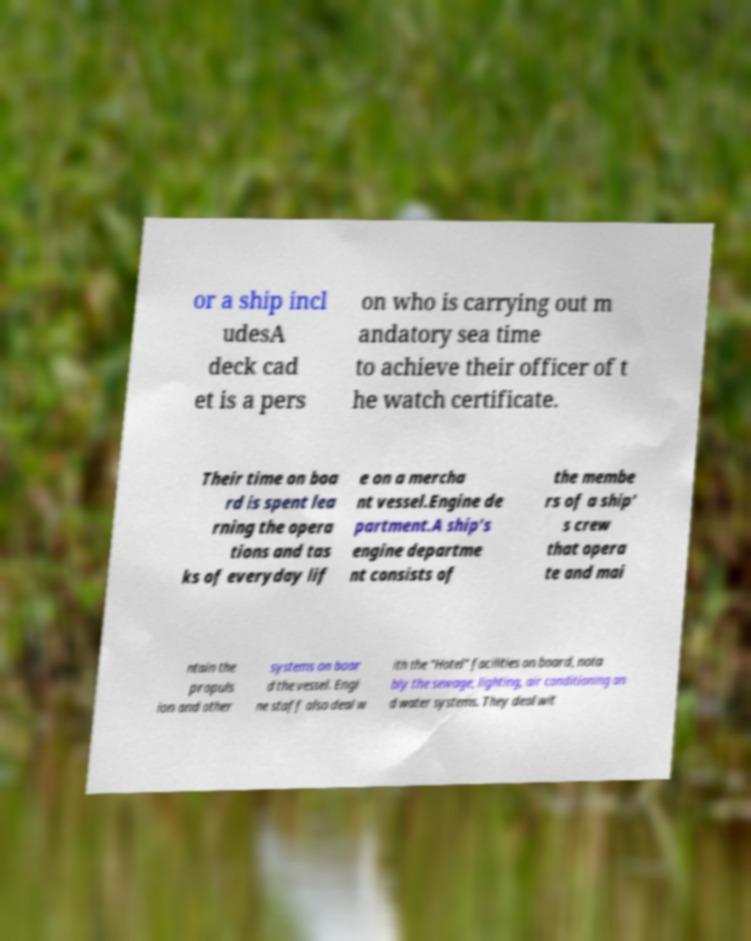Could you extract and type out the text from this image? or a ship incl udesA deck cad et is a pers on who is carrying out m andatory sea time to achieve their officer of t he watch certificate. Their time on boa rd is spent lea rning the opera tions and tas ks of everyday lif e on a mercha nt vessel.Engine de partment.A ship's engine departme nt consists of the membe rs of a ship' s crew that opera te and mai ntain the propuls ion and other systems on boar d the vessel. Engi ne staff also deal w ith the "Hotel" facilities on board, nota bly the sewage, lighting, air conditioning an d water systems. They deal wit 